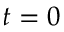Convert formula to latex. <formula><loc_0><loc_0><loc_500><loc_500>t = 0</formula> 